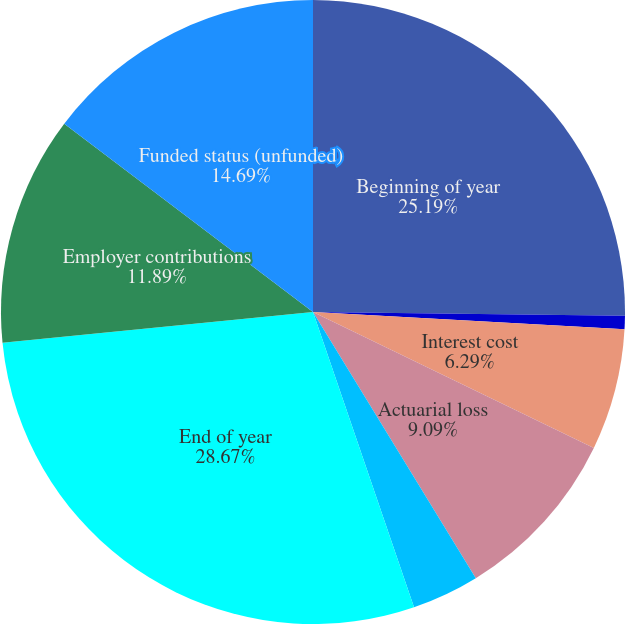<chart> <loc_0><loc_0><loc_500><loc_500><pie_chart><fcel>Beginning of year<fcel>Service cost<fcel>Interest cost<fcel>Actuarial loss<fcel>Benefits paid<fcel>End of year<fcel>Employer contributions<fcel>Funded status (unfunded)<nl><fcel>25.2%<fcel>0.69%<fcel>6.29%<fcel>9.09%<fcel>3.49%<fcel>28.68%<fcel>11.89%<fcel>14.69%<nl></chart> 